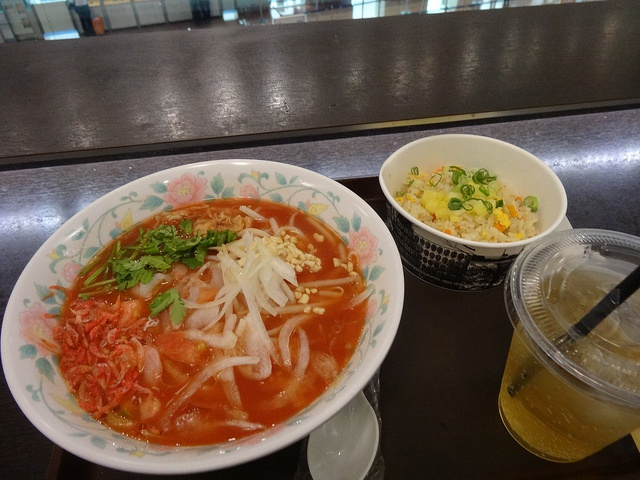Describe the objects in this image and their specific colors. I can see bowl in gray, brown, maroon, darkgray, and tan tones, cup in gray, olive, maroon, and black tones, dining table in gray, black, maroon, olive, and lightgray tones, bowl in gray, tan, and black tones, and spoon in gray and darkgray tones in this image. 